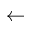Convert formula to latex. <formula><loc_0><loc_0><loc_500><loc_500>\leftarrow</formula> 